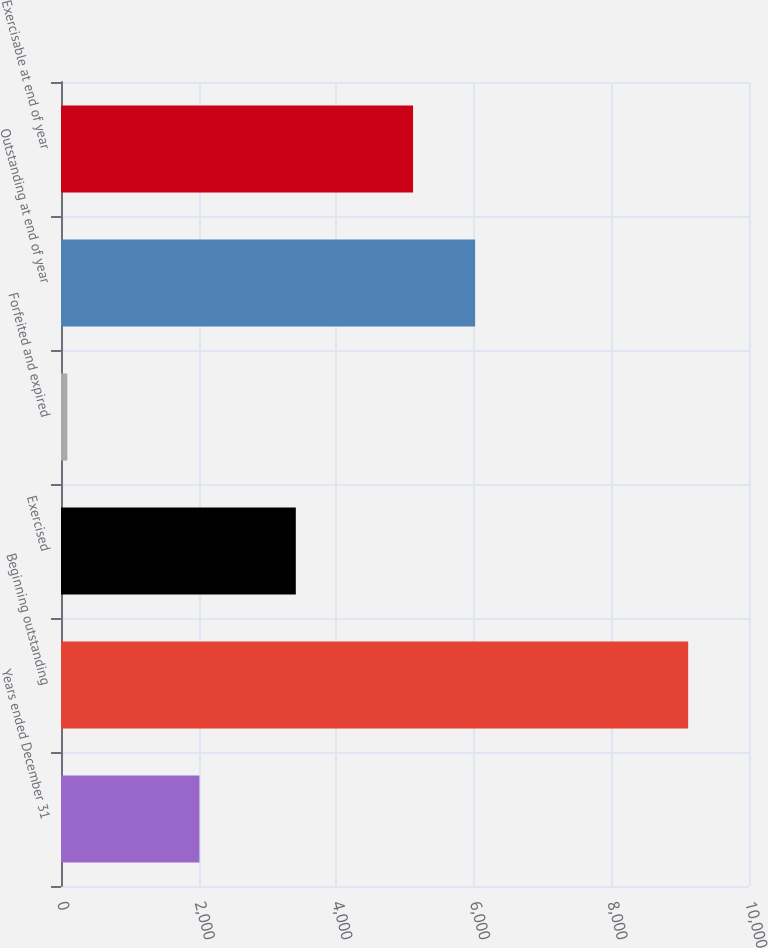<chart> <loc_0><loc_0><loc_500><loc_500><bar_chart><fcel>Years ended December 31<fcel>Beginning outstanding<fcel>Exercised<fcel>Forfeited and expired<fcel>Outstanding at end of year<fcel>Exercisable at end of year<nl><fcel>2012<fcel>9116<fcel>3413<fcel>92<fcel>6019.4<fcel>5117<nl></chart> 